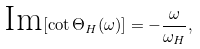<formula> <loc_0><loc_0><loc_500><loc_500>\text {Im} [ \cot \Theta _ { H } ( \omega ) ] = - \frac { \omega } { \omega _ { H } } ,</formula> 